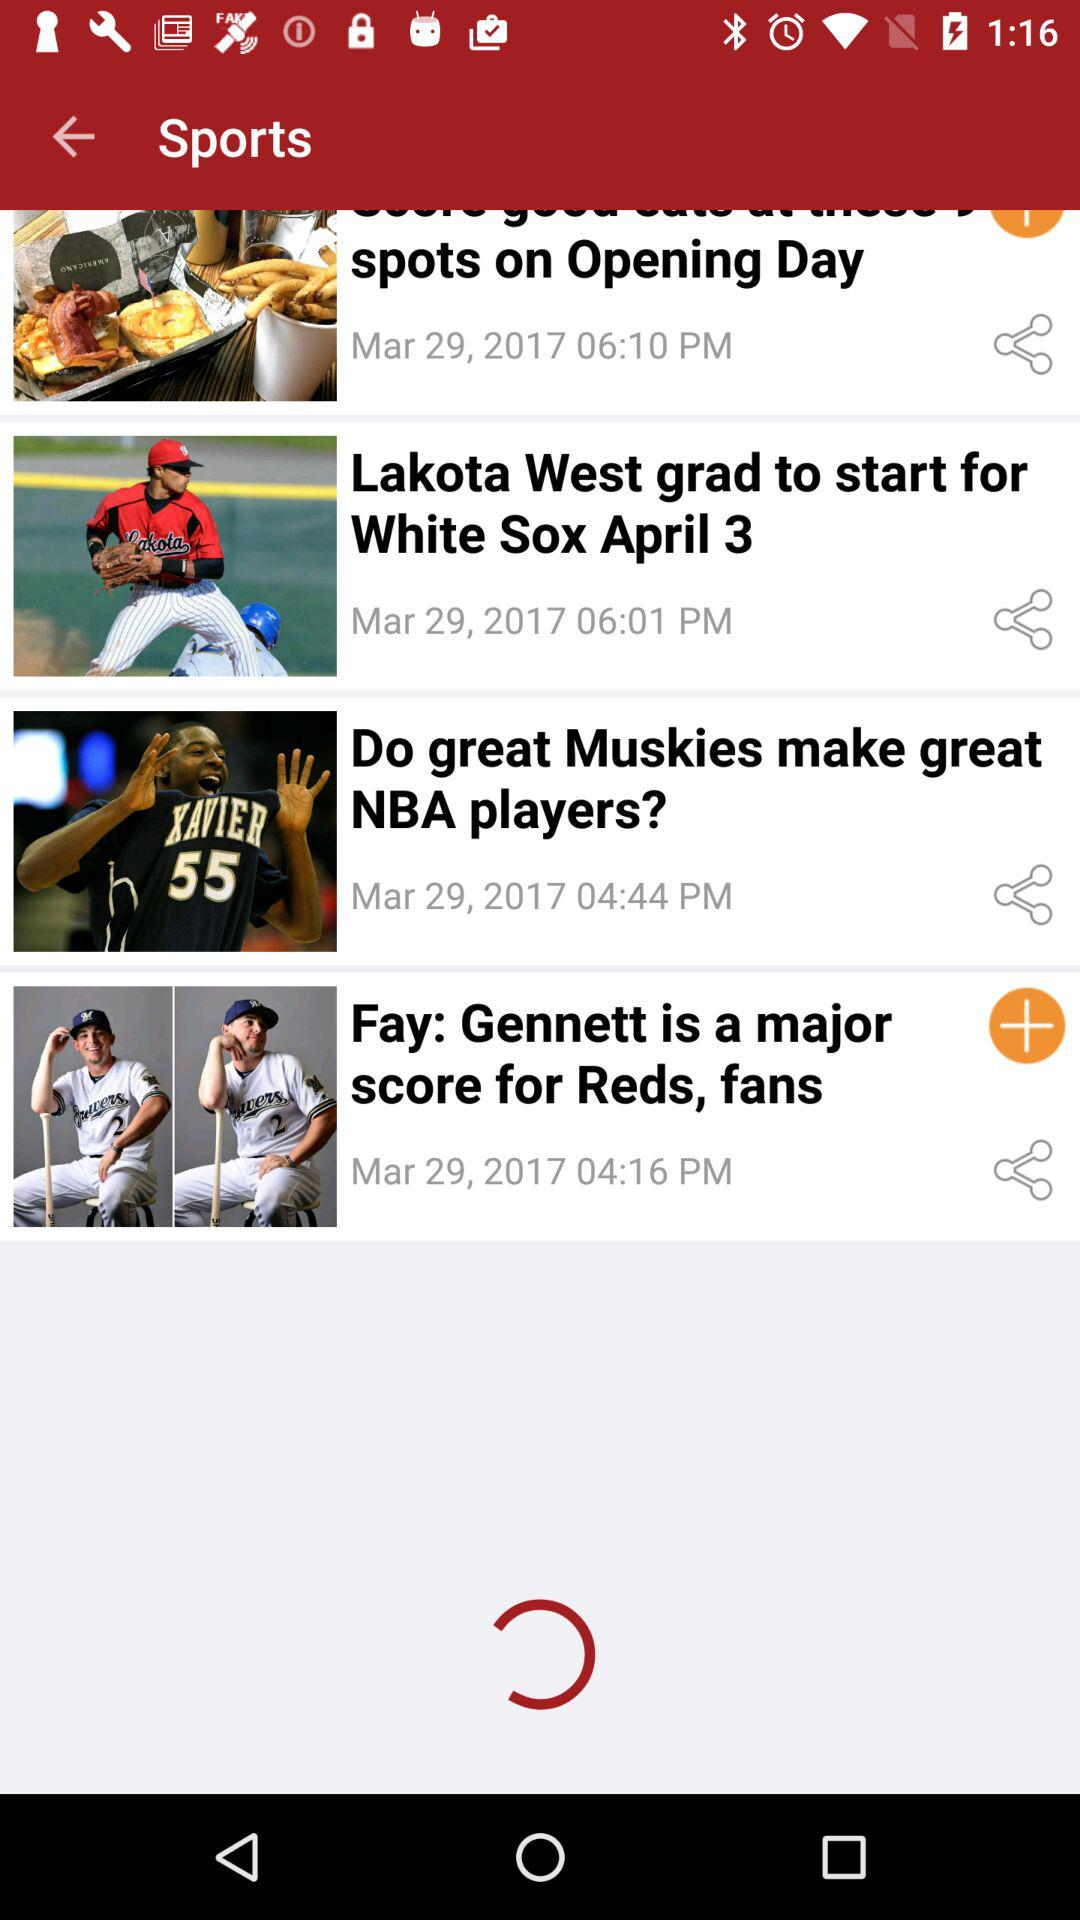Who is a major score for "Reds"? The player Gennett is a major score for "Reds". 